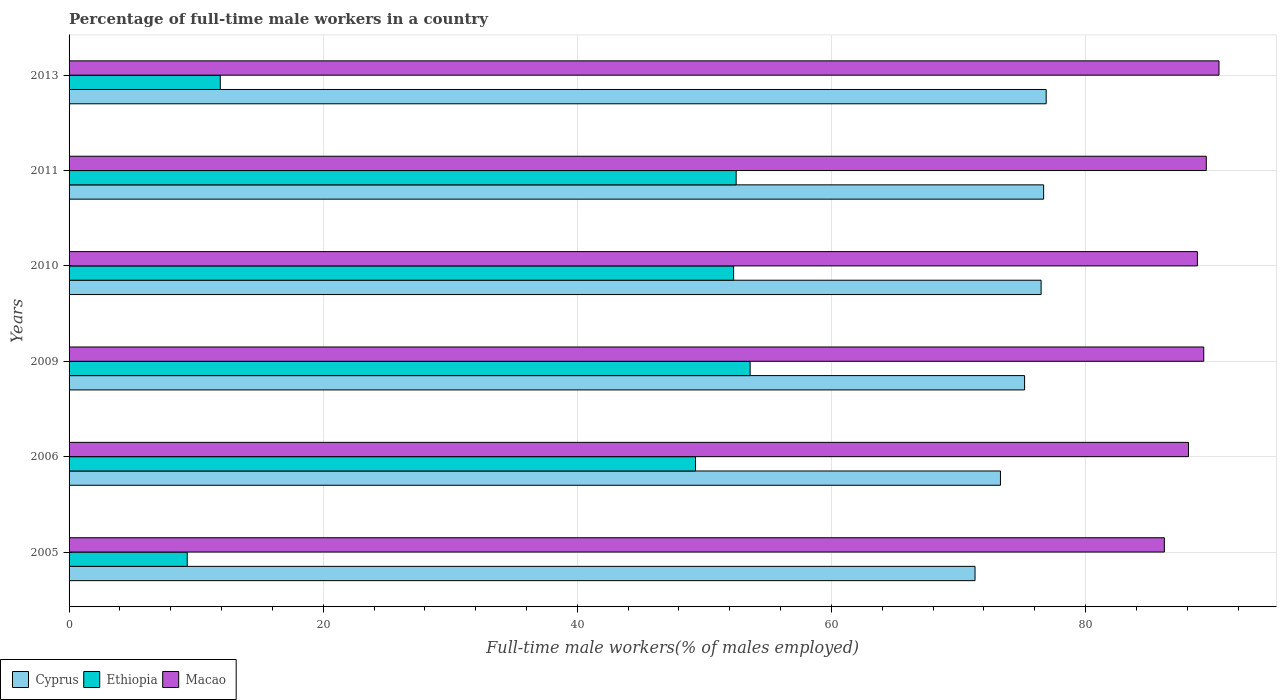How many bars are there on the 5th tick from the top?
Provide a short and direct response. 3. How many bars are there on the 2nd tick from the bottom?
Offer a terse response. 3. What is the label of the 1st group of bars from the top?
Your answer should be compact. 2013. In how many cases, is the number of bars for a given year not equal to the number of legend labels?
Make the answer very short. 0. What is the percentage of full-time male workers in Ethiopia in 2011?
Your answer should be compact. 52.5. Across all years, what is the maximum percentage of full-time male workers in Cyprus?
Your answer should be very brief. 76.9. Across all years, what is the minimum percentage of full-time male workers in Cyprus?
Your answer should be very brief. 71.3. What is the total percentage of full-time male workers in Cyprus in the graph?
Offer a terse response. 449.9. What is the difference between the percentage of full-time male workers in Macao in 2006 and that in 2010?
Your response must be concise. -0.7. What is the difference between the percentage of full-time male workers in Macao in 2006 and the percentage of full-time male workers in Cyprus in 2011?
Offer a very short reply. 11.4. What is the average percentage of full-time male workers in Macao per year?
Your answer should be compact. 88.73. In the year 2005, what is the difference between the percentage of full-time male workers in Cyprus and percentage of full-time male workers in Ethiopia?
Ensure brevity in your answer.  62. What is the ratio of the percentage of full-time male workers in Cyprus in 2006 to that in 2010?
Provide a succinct answer. 0.96. Is the difference between the percentage of full-time male workers in Cyprus in 2009 and 2011 greater than the difference between the percentage of full-time male workers in Ethiopia in 2009 and 2011?
Keep it short and to the point. No. What is the difference between the highest and the second highest percentage of full-time male workers in Cyprus?
Your answer should be compact. 0.2. What is the difference between the highest and the lowest percentage of full-time male workers in Macao?
Your answer should be very brief. 4.3. What does the 3rd bar from the top in 2010 represents?
Your response must be concise. Cyprus. What does the 1st bar from the bottom in 2010 represents?
Offer a terse response. Cyprus. Are the values on the major ticks of X-axis written in scientific E-notation?
Keep it short and to the point. No. Does the graph contain any zero values?
Your response must be concise. No. How many legend labels are there?
Your answer should be compact. 3. What is the title of the graph?
Your answer should be very brief. Percentage of full-time male workers in a country. Does "Sierra Leone" appear as one of the legend labels in the graph?
Offer a terse response. No. What is the label or title of the X-axis?
Offer a very short reply. Full-time male workers(% of males employed). What is the Full-time male workers(% of males employed) of Cyprus in 2005?
Provide a succinct answer. 71.3. What is the Full-time male workers(% of males employed) in Ethiopia in 2005?
Your answer should be very brief. 9.3. What is the Full-time male workers(% of males employed) of Macao in 2005?
Give a very brief answer. 86.2. What is the Full-time male workers(% of males employed) in Cyprus in 2006?
Provide a succinct answer. 73.3. What is the Full-time male workers(% of males employed) in Ethiopia in 2006?
Give a very brief answer. 49.3. What is the Full-time male workers(% of males employed) in Macao in 2006?
Make the answer very short. 88.1. What is the Full-time male workers(% of males employed) in Cyprus in 2009?
Make the answer very short. 75.2. What is the Full-time male workers(% of males employed) in Ethiopia in 2009?
Offer a very short reply. 53.6. What is the Full-time male workers(% of males employed) of Macao in 2009?
Your answer should be compact. 89.3. What is the Full-time male workers(% of males employed) of Cyprus in 2010?
Make the answer very short. 76.5. What is the Full-time male workers(% of males employed) in Ethiopia in 2010?
Make the answer very short. 52.3. What is the Full-time male workers(% of males employed) of Macao in 2010?
Provide a short and direct response. 88.8. What is the Full-time male workers(% of males employed) of Cyprus in 2011?
Offer a terse response. 76.7. What is the Full-time male workers(% of males employed) of Ethiopia in 2011?
Ensure brevity in your answer.  52.5. What is the Full-time male workers(% of males employed) of Macao in 2011?
Provide a short and direct response. 89.5. What is the Full-time male workers(% of males employed) in Cyprus in 2013?
Offer a very short reply. 76.9. What is the Full-time male workers(% of males employed) in Ethiopia in 2013?
Your response must be concise. 11.9. What is the Full-time male workers(% of males employed) in Macao in 2013?
Provide a short and direct response. 90.5. Across all years, what is the maximum Full-time male workers(% of males employed) of Cyprus?
Offer a very short reply. 76.9. Across all years, what is the maximum Full-time male workers(% of males employed) in Ethiopia?
Give a very brief answer. 53.6. Across all years, what is the maximum Full-time male workers(% of males employed) of Macao?
Keep it short and to the point. 90.5. Across all years, what is the minimum Full-time male workers(% of males employed) in Cyprus?
Offer a terse response. 71.3. Across all years, what is the minimum Full-time male workers(% of males employed) in Ethiopia?
Provide a short and direct response. 9.3. Across all years, what is the minimum Full-time male workers(% of males employed) of Macao?
Make the answer very short. 86.2. What is the total Full-time male workers(% of males employed) in Cyprus in the graph?
Your response must be concise. 449.9. What is the total Full-time male workers(% of males employed) in Ethiopia in the graph?
Offer a very short reply. 228.9. What is the total Full-time male workers(% of males employed) in Macao in the graph?
Provide a succinct answer. 532.4. What is the difference between the Full-time male workers(% of males employed) of Macao in 2005 and that in 2006?
Your answer should be very brief. -1.9. What is the difference between the Full-time male workers(% of males employed) in Ethiopia in 2005 and that in 2009?
Give a very brief answer. -44.3. What is the difference between the Full-time male workers(% of males employed) of Ethiopia in 2005 and that in 2010?
Provide a succinct answer. -43. What is the difference between the Full-time male workers(% of males employed) in Macao in 2005 and that in 2010?
Provide a succinct answer. -2.6. What is the difference between the Full-time male workers(% of males employed) of Cyprus in 2005 and that in 2011?
Ensure brevity in your answer.  -5.4. What is the difference between the Full-time male workers(% of males employed) of Ethiopia in 2005 and that in 2011?
Offer a very short reply. -43.2. What is the difference between the Full-time male workers(% of males employed) of Macao in 2005 and that in 2011?
Keep it short and to the point. -3.3. What is the difference between the Full-time male workers(% of males employed) in Ethiopia in 2005 and that in 2013?
Make the answer very short. -2.6. What is the difference between the Full-time male workers(% of males employed) in Macao in 2005 and that in 2013?
Your answer should be compact. -4.3. What is the difference between the Full-time male workers(% of males employed) in Macao in 2006 and that in 2009?
Give a very brief answer. -1.2. What is the difference between the Full-time male workers(% of males employed) of Cyprus in 2006 and that in 2010?
Provide a succinct answer. -3.2. What is the difference between the Full-time male workers(% of males employed) in Ethiopia in 2006 and that in 2010?
Your answer should be very brief. -3. What is the difference between the Full-time male workers(% of males employed) in Cyprus in 2006 and that in 2011?
Give a very brief answer. -3.4. What is the difference between the Full-time male workers(% of males employed) in Macao in 2006 and that in 2011?
Ensure brevity in your answer.  -1.4. What is the difference between the Full-time male workers(% of males employed) of Ethiopia in 2006 and that in 2013?
Offer a very short reply. 37.4. What is the difference between the Full-time male workers(% of males employed) of Macao in 2006 and that in 2013?
Make the answer very short. -2.4. What is the difference between the Full-time male workers(% of males employed) of Ethiopia in 2009 and that in 2010?
Your answer should be compact. 1.3. What is the difference between the Full-time male workers(% of males employed) of Macao in 2009 and that in 2010?
Provide a succinct answer. 0.5. What is the difference between the Full-time male workers(% of males employed) of Cyprus in 2009 and that in 2011?
Your response must be concise. -1.5. What is the difference between the Full-time male workers(% of males employed) of Ethiopia in 2009 and that in 2011?
Provide a short and direct response. 1.1. What is the difference between the Full-time male workers(% of males employed) of Macao in 2009 and that in 2011?
Offer a very short reply. -0.2. What is the difference between the Full-time male workers(% of males employed) of Ethiopia in 2009 and that in 2013?
Keep it short and to the point. 41.7. What is the difference between the Full-time male workers(% of males employed) in Cyprus in 2010 and that in 2013?
Make the answer very short. -0.4. What is the difference between the Full-time male workers(% of males employed) of Ethiopia in 2010 and that in 2013?
Your answer should be compact. 40.4. What is the difference between the Full-time male workers(% of males employed) in Macao in 2010 and that in 2013?
Ensure brevity in your answer.  -1.7. What is the difference between the Full-time male workers(% of males employed) in Cyprus in 2011 and that in 2013?
Keep it short and to the point. -0.2. What is the difference between the Full-time male workers(% of males employed) of Ethiopia in 2011 and that in 2013?
Provide a short and direct response. 40.6. What is the difference between the Full-time male workers(% of males employed) of Macao in 2011 and that in 2013?
Provide a short and direct response. -1. What is the difference between the Full-time male workers(% of males employed) of Cyprus in 2005 and the Full-time male workers(% of males employed) of Macao in 2006?
Ensure brevity in your answer.  -16.8. What is the difference between the Full-time male workers(% of males employed) of Ethiopia in 2005 and the Full-time male workers(% of males employed) of Macao in 2006?
Give a very brief answer. -78.8. What is the difference between the Full-time male workers(% of males employed) of Cyprus in 2005 and the Full-time male workers(% of males employed) of Ethiopia in 2009?
Offer a very short reply. 17.7. What is the difference between the Full-time male workers(% of males employed) in Ethiopia in 2005 and the Full-time male workers(% of males employed) in Macao in 2009?
Offer a very short reply. -80. What is the difference between the Full-time male workers(% of males employed) of Cyprus in 2005 and the Full-time male workers(% of males employed) of Ethiopia in 2010?
Offer a terse response. 19. What is the difference between the Full-time male workers(% of males employed) in Cyprus in 2005 and the Full-time male workers(% of males employed) in Macao in 2010?
Your answer should be very brief. -17.5. What is the difference between the Full-time male workers(% of males employed) in Ethiopia in 2005 and the Full-time male workers(% of males employed) in Macao in 2010?
Offer a terse response. -79.5. What is the difference between the Full-time male workers(% of males employed) of Cyprus in 2005 and the Full-time male workers(% of males employed) of Macao in 2011?
Make the answer very short. -18.2. What is the difference between the Full-time male workers(% of males employed) in Ethiopia in 2005 and the Full-time male workers(% of males employed) in Macao in 2011?
Keep it short and to the point. -80.2. What is the difference between the Full-time male workers(% of males employed) of Cyprus in 2005 and the Full-time male workers(% of males employed) of Ethiopia in 2013?
Your response must be concise. 59.4. What is the difference between the Full-time male workers(% of males employed) of Cyprus in 2005 and the Full-time male workers(% of males employed) of Macao in 2013?
Offer a terse response. -19.2. What is the difference between the Full-time male workers(% of males employed) of Ethiopia in 2005 and the Full-time male workers(% of males employed) of Macao in 2013?
Your answer should be very brief. -81.2. What is the difference between the Full-time male workers(% of males employed) of Ethiopia in 2006 and the Full-time male workers(% of males employed) of Macao in 2009?
Give a very brief answer. -40. What is the difference between the Full-time male workers(% of males employed) in Cyprus in 2006 and the Full-time male workers(% of males employed) in Macao in 2010?
Offer a very short reply. -15.5. What is the difference between the Full-time male workers(% of males employed) in Ethiopia in 2006 and the Full-time male workers(% of males employed) in Macao in 2010?
Ensure brevity in your answer.  -39.5. What is the difference between the Full-time male workers(% of males employed) in Cyprus in 2006 and the Full-time male workers(% of males employed) in Ethiopia in 2011?
Keep it short and to the point. 20.8. What is the difference between the Full-time male workers(% of males employed) of Cyprus in 2006 and the Full-time male workers(% of males employed) of Macao in 2011?
Ensure brevity in your answer.  -16.2. What is the difference between the Full-time male workers(% of males employed) in Ethiopia in 2006 and the Full-time male workers(% of males employed) in Macao in 2011?
Your answer should be compact. -40.2. What is the difference between the Full-time male workers(% of males employed) of Cyprus in 2006 and the Full-time male workers(% of males employed) of Ethiopia in 2013?
Make the answer very short. 61.4. What is the difference between the Full-time male workers(% of males employed) of Cyprus in 2006 and the Full-time male workers(% of males employed) of Macao in 2013?
Make the answer very short. -17.2. What is the difference between the Full-time male workers(% of males employed) in Ethiopia in 2006 and the Full-time male workers(% of males employed) in Macao in 2013?
Your response must be concise. -41.2. What is the difference between the Full-time male workers(% of males employed) in Cyprus in 2009 and the Full-time male workers(% of males employed) in Ethiopia in 2010?
Keep it short and to the point. 22.9. What is the difference between the Full-time male workers(% of males employed) in Ethiopia in 2009 and the Full-time male workers(% of males employed) in Macao in 2010?
Keep it short and to the point. -35.2. What is the difference between the Full-time male workers(% of males employed) in Cyprus in 2009 and the Full-time male workers(% of males employed) in Ethiopia in 2011?
Provide a succinct answer. 22.7. What is the difference between the Full-time male workers(% of males employed) in Cyprus in 2009 and the Full-time male workers(% of males employed) in Macao in 2011?
Offer a terse response. -14.3. What is the difference between the Full-time male workers(% of males employed) of Ethiopia in 2009 and the Full-time male workers(% of males employed) of Macao in 2011?
Your answer should be very brief. -35.9. What is the difference between the Full-time male workers(% of males employed) of Cyprus in 2009 and the Full-time male workers(% of males employed) of Ethiopia in 2013?
Your answer should be very brief. 63.3. What is the difference between the Full-time male workers(% of males employed) of Cyprus in 2009 and the Full-time male workers(% of males employed) of Macao in 2013?
Your answer should be compact. -15.3. What is the difference between the Full-time male workers(% of males employed) of Ethiopia in 2009 and the Full-time male workers(% of males employed) of Macao in 2013?
Make the answer very short. -36.9. What is the difference between the Full-time male workers(% of males employed) in Cyprus in 2010 and the Full-time male workers(% of males employed) in Ethiopia in 2011?
Your answer should be compact. 24. What is the difference between the Full-time male workers(% of males employed) in Ethiopia in 2010 and the Full-time male workers(% of males employed) in Macao in 2011?
Provide a short and direct response. -37.2. What is the difference between the Full-time male workers(% of males employed) in Cyprus in 2010 and the Full-time male workers(% of males employed) in Ethiopia in 2013?
Keep it short and to the point. 64.6. What is the difference between the Full-time male workers(% of males employed) in Cyprus in 2010 and the Full-time male workers(% of males employed) in Macao in 2013?
Your answer should be very brief. -14. What is the difference between the Full-time male workers(% of males employed) in Ethiopia in 2010 and the Full-time male workers(% of males employed) in Macao in 2013?
Offer a very short reply. -38.2. What is the difference between the Full-time male workers(% of males employed) in Cyprus in 2011 and the Full-time male workers(% of males employed) in Ethiopia in 2013?
Provide a succinct answer. 64.8. What is the difference between the Full-time male workers(% of males employed) in Ethiopia in 2011 and the Full-time male workers(% of males employed) in Macao in 2013?
Offer a very short reply. -38. What is the average Full-time male workers(% of males employed) of Cyprus per year?
Offer a terse response. 74.98. What is the average Full-time male workers(% of males employed) of Ethiopia per year?
Provide a short and direct response. 38.15. What is the average Full-time male workers(% of males employed) of Macao per year?
Your answer should be compact. 88.73. In the year 2005, what is the difference between the Full-time male workers(% of males employed) of Cyprus and Full-time male workers(% of males employed) of Macao?
Your answer should be very brief. -14.9. In the year 2005, what is the difference between the Full-time male workers(% of males employed) of Ethiopia and Full-time male workers(% of males employed) of Macao?
Make the answer very short. -76.9. In the year 2006, what is the difference between the Full-time male workers(% of males employed) in Cyprus and Full-time male workers(% of males employed) in Ethiopia?
Make the answer very short. 24. In the year 2006, what is the difference between the Full-time male workers(% of males employed) of Cyprus and Full-time male workers(% of males employed) of Macao?
Make the answer very short. -14.8. In the year 2006, what is the difference between the Full-time male workers(% of males employed) of Ethiopia and Full-time male workers(% of males employed) of Macao?
Your answer should be compact. -38.8. In the year 2009, what is the difference between the Full-time male workers(% of males employed) in Cyprus and Full-time male workers(% of males employed) in Ethiopia?
Provide a short and direct response. 21.6. In the year 2009, what is the difference between the Full-time male workers(% of males employed) in Cyprus and Full-time male workers(% of males employed) in Macao?
Ensure brevity in your answer.  -14.1. In the year 2009, what is the difference between the Full-time male workers(% of males employed) of Ethiopia and Full-time male workers(% of males employed) of Macao?
Provide a short and direct response. -35.7. In the year 2010, what is the difference between the Full-time male workers(% of males employed) in Cyprus and Full-time male workers(% of males employed) in Ethiopia?
Give a very brief answer. 24.2. In the year 2010, what is the difference between the Full-time male workers(% of males employed) in Ethiopia and Full-time male workers(% of males employed) in Macao?
Offer a very short reply. -36.5. In the year 2011, what is the difference between the Full-time male workers(% of males employed) of Cyprus and Full-time male workers(% of males employed) of Ethiopia?
Your answer should be compact. 24.2. In the year 2011, what is the difference between the Full-time male workers(% of males employed) of Cyprus and Full-time male workers(% of males employed) of Macao?
Keep it short and to the point. -12.8. In the year 2011, what is the difference between the Full-time male workers(% of males employed) in Ethiopia and Full-time male workers(% of males employed) in Macao?
Your answer should be very brief. -37. In the year 2013, what is the difference between the Full-time male workers(% of males employed) of Ethiopia and Full-time male workers(% of males employed) of Macao?
Provide a short and direct response. -78.6. What is the ratio of the Full-time male workers(% of males employed) in Cyprus in 2005 to that in 2006?
Your response must be concise. 0.97. What is the ratio of the Full-time male workers(% of males employed) of Ethiopia in 2005 to that in 2006?
Give a very brief answer. 0.19. What is the ratio of the Full-time male workers(% of males employed) in Macao in 2005 to that in 2006?
Your response must be concise. 0.98. What is the ratio of the Full-time male workers(% of males employed) in Cyprus in 2005 to that in 2009?
Your answer should be compact. 0.95. What is the ratio of the Full-time male workers(% of males employed) of Ethiopia in 2005 to that in 2009?
Your response must be concise. 0.17. What is the ratio of the Full-time male workers(% of males employed) of Macao in 2005 to that in 2009?
Provide a succinct answer. 0.97. What is the ratio of the Full-time male workers(% of males employed) of Cyprus in 2005 to that in 2010?
Offer a terse response. 0.93. What is the ratio of the Full-time male workers(% of males employed) in Ethiopia in 2005 to that in 2010?
Your answer should be compact. 0.18. What is the ratio of the Full-time male workers(% of males employed) in Macao in 2005 to that in 2010?
Provide a succinct answer. 0.97. What is the ratio of the Full-time male workers(% of males employed) of Cyprus in 2005 to that in 2011?
Your answer should be compact. 0.93. What is the ratio of the Full-time male workers(% of males employed) of Ethiopia in 2005 to that in 2011?
Offer a terse response. 0.18. What is the ratio of the Full-time male workers(% of males employed) of Macao in 2005 to that in 2011?
Provide a succinct answer. 0.96. What is the ratio of the Full-time male workers(% of males employed) of Cyprus in 2005 to that in 2013?
Offer a terse response. 0.93. What is the ratio of the Full-time male workers(% of males employed) of Ethiopia in 2005 to that in 2013?
Provide a short and direct response. 0.78. What is the ratio of the Full-time male workers(% of males employed) in Macao in 2005 to that in 2013?
Ensure brevity in your answer.  0.95. What is the ratio of the Full-time male workers(% of males employed) in Cyprus in 2006 to that in 2009?
Ensure brevity in your answer.  0.97. What is the ratio of the Full-time male workers(% of males employed) in Ethiopia in 2006 to that in 2009?
Ensure brevity in your answer.  0.92. What is the ratio of the Full-time male workers(% of males employed) in Macao in 2006 to that in 2009?
Your answer should be very brief. 0.99. What is the ratio of the Full-time male workers(% of males employed) in Cyprus in 2006 to that in 2010?
Your response must be concise. 0.96. What is the ratio of the Full-time male workers(% of males employed) in Ethiopia in 2006 to that in 2010?
Provide a short and direct response. 0.94. What is the ratio of the Full-time male workers(% of males employed) in Cyprus in 2006 to that in 2011?
Offer a terse response. 0.96. What is the ratio of the Full-time male workers(% of males employed) of Ethiopia in 2006 to that in 2011?
Keep it short and to the point. 0.94. What is the ratio of the Full-time male workers(% of males employed) of Macao in 2006 to that in 2011?
Give a very brief answer. 0.98. What is the ratio of the Full-time male workers(% of males employed) of Cyprus in 2006 to that in 2013?
Ensure brevity in your answer.  0.95. What is the ratio of the Full-time male workers(% of males employed) in Ethiopia in 2006 to that in 2013?
Your answer should be compact. 4.14. What is the ratio of the Full-time male workers(% of males employed) in Macao in 2006 to that in 2013?
Make the answer very short. 0.97. What is the ratio of the Full-time male workers(% of males employed) in Cyprus in 2009 to that in 2010?
Provide a succinct answer. 0.98. What is the ratio of the Full-time male workers(% of males employed) of Ethiopia in 2009 to that in 2010?
Your answer should be very brief. 1.02. What is the ratio of the Full-time male workers(% of males employed) of Macao in 2009 to that in 2010?
Your answer should be compact. 1.01. What is the ratio of the Full-time male workers(% of males employed) in Cyprus in 2009 to that in 2011?
Give a very brief answer. 0.98. What is the ratio of the Full-time male workers(% of males employed) of Ethiopia in 2009 to that in 2011?
Ensure brevity in your answer.  1.02. What is the ratio of the Full-time male workers(% of males employed) in Macao in 2009 to that in 2011?
Your answer should be very brief. 1. What is the ratio of the Full-time male workers(% of males employed) in Cyprus in 2009 to that in 2013?
Offer a terse response. 0.98. What is the ratio of the Full-time male workers(% of males employed) of Ethiopia in 2009 to that in 2013?
Give a very brief answer. 4.5. What is the ratio of the Full-time male workers(% of males employed) in Macao in 2009 to that in 2013?
Your response must be concise. 0.99. What is the ratio of the Full-time male workers(% of males employed) in Cyprus in 2010 to that in 2011?
Offer a terse response. 1. What is the ratio of the Full-time male workers(% of males employed) in Ethiopia in 2010 to that in 2013?
Provide a short and direct response. 4.39. What is the ratio of the Full-time male workers(% of males employed) of Macao in 2010 to that in 2013?
Offer a terse response. 0.98. What is the ratio of the Full-time male workers(% of males employed) of Cyprus in 2011 to that in 2013?
Your answer should be compact. 1. What is the ratio of the Full-time male workers(% of males employed) of Ethiopia in 2011 to that in 2013?
Offer a very short reply. 4.41. What is the ratio of the Full-time male workers(% of males employed) of Macao in 2011 to that in 2013?
Keep it short and to the point. 0.99. What is the difference between the highest and the lowest Full-time male workers(% of males employed) in Cyprus?
Your response must be concise. 5.6. What is the difference between the highest and the lowest Full-time male workers(% of males employed) of Ethiopia?
Keep it short and to the point. 44.3. 